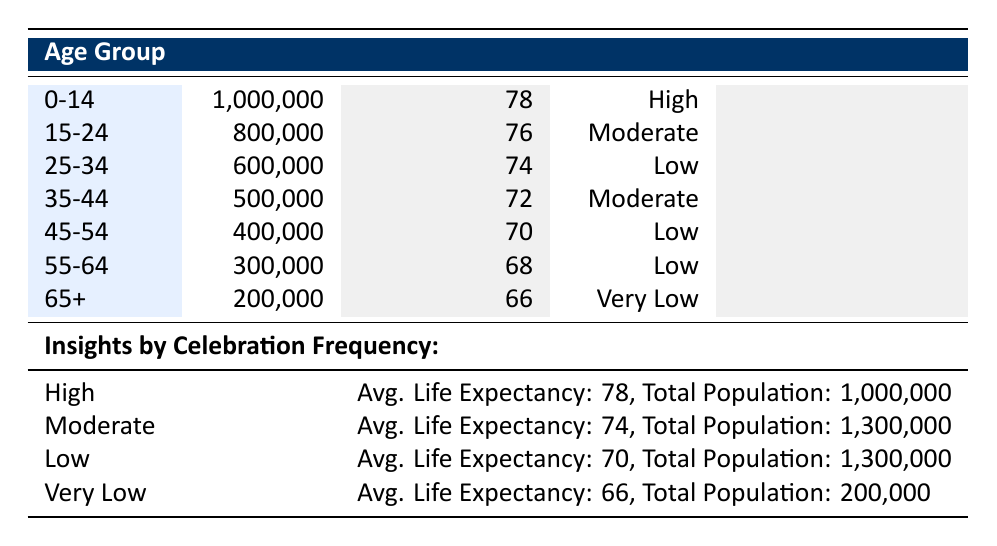What is the life expectancy for the age group 25-34? From the table, you can find the life expectancy directly listed next to the age group 25-34, which shows 74 years.
Answer: 74 What is the total population of the age group 45-54? The total population for the age group 45-54 is indicated in the corresponding row of the table, which is 400,000.
Answer: 400,000 How does the average life expectancy of the High celebration frequency group compare to the Low celebration frequency group? According to the insights, the average life expectancy for the High group is 78 years, while for the Low group it is 70 years. The difference is 78 - 70 = 8 years.
Answer: 8 years Is it true that the 65+ age group has a higher life expectancy than the 55-64 age group? From the table, the life expectancy for the 65+ age group is 66 years, while for the 55-64 age group it is 68 years. Since 66 is less than 68, the statement is false.
Answer: False What is the average life expectancy for the Moderate celebration frequency group, and how does it compare to the Very Low group? The Moderate group has an average life expectancy of 74 years and the Very Low group has 66 years. To compare, 74 - 66 = 8 years. Thus, the Moderate group has an average life expectancy that is 8 years higher than the Very Low group.
Answer: 8 years What is the percentage representation of the population in the High celebration frequency category compared to the total population across all categories? The High celebration frequency group has a total population of 1,000,000. The total population across all groups is 1,000,000 + 1,300,000 + 1,300,000 + 200,000 = 3,800,000. To find the percentage: (1,000,000 / 3,800,000) * 100 ≈ 26.32%.
Answer: 26.32% How many people in the age group 15-24 celebrate holidays at a Moderate frequency? The population for the age group 15-24, celebrating holidays at a Moderate frequency, is directly listed as 800,000.
Answer: 800,000 If the Low celebration frequency group were to increase its population by 10%, what would the new population be? The current population of the Low celebration frequency group is 1,300,000. An increase of 10% means calculating 1,300,000 * 0.10 = 130,000. Thus, the new population would be 1,300,000 + 130,000 = 1,430,000.
Answer: 1,430,000 What is the average life expectancy across all four categories of holiday celebration frequency? Adding the average life expectancies: 78 (High) + 74 (Moderate) + 70 (Low) + 66 (Very Low) = 288. There are 4 groups, so the average is 288 / 4 = 72.
Answer: 72 